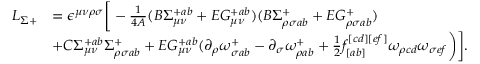Convert formula to latex. <formula><loc_0><loc_0><loc_500><loc_500>\begin{array} { l l } { { L _ { \Sigma + } } } & { { = \epsilon ^ { \mu \nu \rho \sigma } \Big [ - \frac { 1 } { 4 A } ( B \Sigma _ { \mu \nu } ^ { + a b } + E G _ { \mu \nu } ^ { + a b } ) ( B \Sigma _ { \rho \sigma a b } ^ { + } + E G _ { \rho \sigma a b } ^ { + } ) } } & { { + C \Sigma _ { \mu \nu } ^ { + a b } \Sigma _ { \rho \sigma a b } ^ { + } + E G _ { \mu \nu } ^ { + a b } ( \partial _ { \rho } \omega _ { \sigma a b } ^ { + } - \partial _ { \sigma } \omega _ { \rho a b } ^ { + } + { \frac { 1 } { 2 } } f _ { [ a b ] } ^ { [ c d ] [ e f ] } \omega _ { \rho c d } \omega _ { \sigma e f } \Big ) \Big ] . } } \end{array}</formula> 